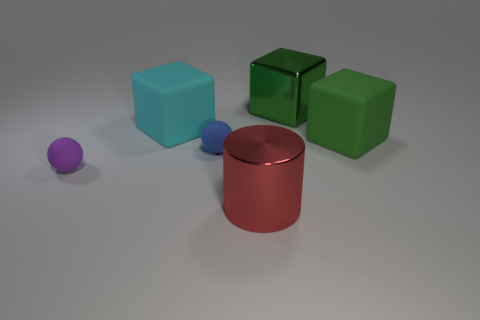Add 2 small rubber things. How many objects exist? 8 Subtract all spheres. How many objects are left? 4 Subtract 0 yellow balls. How many objects are left? 6 Subtract all small blue metallic cylinders. Subtract all balls. How many objects are left? 4 Add 5 large green things. How many large green things are left? 7 Add 4 red shiny things. How many red shiny things exist? 5 